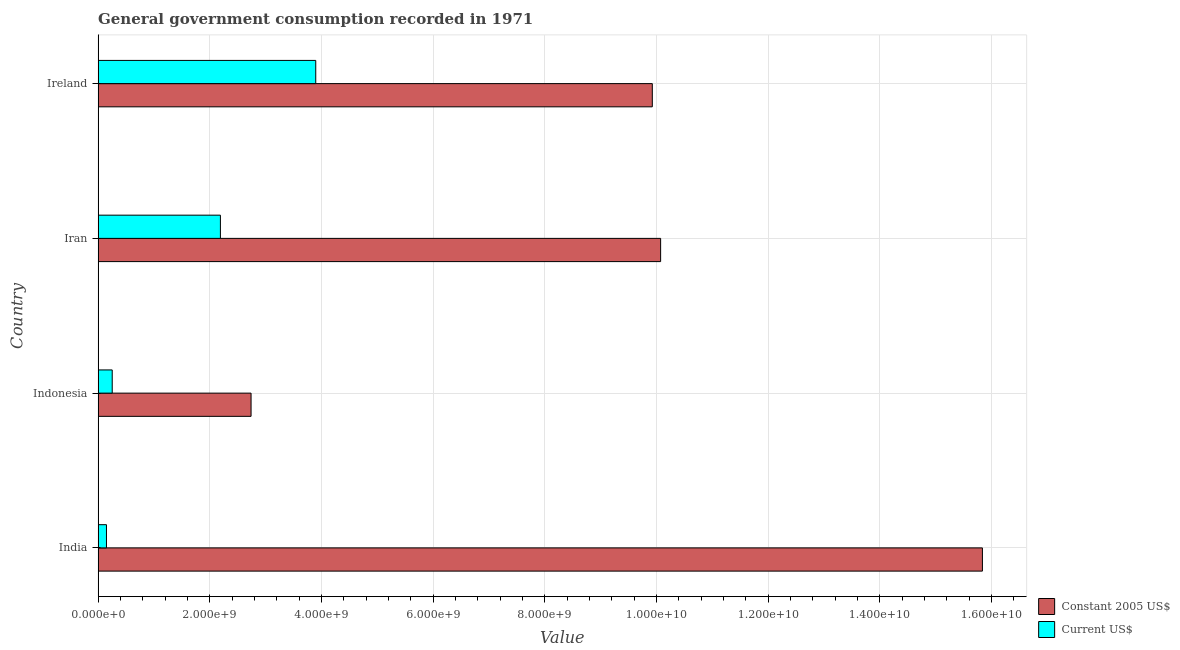How many bars are there on the 4th tick from the bottom?
Ensure brevity in your answer.  2. What is the label of the 4th group of bars from the top?
Ensure brevity in your answer.  India. What is the value consumed in constant 2005 us$ in Indonesia?
Keep it short and to the point. 2.74e+09. Across all countries, what is the maximum value consumed in current us$?
Make the answer very short. 3.90e+09. Across all countries, what is the minimum value consumed in constant 2005 us$?
Your answer should be very brief. 2.74e+09. In which country was the value consumed in constant 2005 us$ minimum?
Give a very brief answer. Indonesia. What is the total value consumed in current us$ in the graph?
Make the answer very short. 6.49e+09. What is the difference between the value consumed in constant 2005 us$ in Indonesia and that in Iran?
Offer a very short reply. -7.33e+09. What is the difference between the value consumed in current us$ in Iran and the value consumed in constant 2005 us$ in Ireland?
Give a very brief answer. -7.73e+09. What is the average value consumed in constant 2005 us$ per country?
Offer a very short reply. 9.64e+09. What is the difference between the value consumed in constant 2005 us$ and value consumed in current us$ in Indonesia?
Offer a very short reply. 2.49e+09. In how many countries, is the value consumed in constant 2005 us$ greater than 13600000000 ?
Offer a terse response. 1. What is the ratio of the value consumed in current us$ in India to that in Ireland?
Offer a very short reply. 0.04. Is the value consumed in constant 2005 us$ in Iran less than that in Ireland?
Your answer should be compact. No. Is the difference between the value consumed in current us$ in India and Iran greater than the difference between the value consumed in constant 2005 us$ in India and Iran?
Your answer should be compact. No. What is the difference between the highest and the second highest value consumed in current us$?
Ensure brevity in your answer.  1.71e+09. What is the difference between the highest and the lowest value consumed in constant 2005 us$?
Your response must be concise. 1.31e+1. In how many countries, is the value consumed in constant 2005 us$ greater than the average value consumed in constant 2005 us$ taken over all countries?
Ensure brevity in your answer.  3. What does the 1st bar from the top in Ireland represents?
Ensure brevity in your answer.  Current US$. What does the 2nd bar from the bottom in Ireland represents?
Offer a very short reply. Current US$. How many bars are there?
Make the answer very short. 8. Does the graph contain any zero values?
Your answer should be compact. No. Does the graph contain grids?
Your answer should be very brief. Yes. Where does the legend appear in the graph?
Keep it short and to the point. Bottom right. How are the legend labels stacked?
Ensure brevity in your answer.  Vertical. What is the title of the graph?
Offer a very short reply. General government consumption recorded in 1971. What is the label or title of the X-axis?
Offer a very short reply. Value. What is the Value in Constant 2005 US$ in India?
Offer a terse response. 1.58e+1. What is the Value in Current US$ in India?
Provide a succinct answer. 1.49e+08. What is the Value in Constant 2005 US$ in Indonesia?
Provide a short and direct response. 2.74e+09. What is the Value of Current US$ in Indonesia?
Provide a succinct answer. 2.52e+08. What is the Value in Constant 2005 US$ in Iran?
Provide a short and direct response. 1.01e+1. What is the Value of Current US$ in Iran?
Offer a very short reply. 2.19e+09. What is the Value of Constant 2005 US$ in Ireland?
Your answer should be compact. 9.92e+09. What is the Value in Current US$ in Ireland?
Make the answer very short. 3.90e+09. Across all countries, what is the maximum Value of Constant 2005 US$?
Your answer should be compact. 1.58e+1. Across all countries, what is the maximum Value in Current US$?
Your response must be concise. 3.90e+09. Across all countries, what is the minimum Value in Constant 2005 US$?
Keep it short and to the point. 2.74e+09. Across all countries, what is the minimum Value in Current US$?
Offer a terse response. 1.49e+08. What is the total Value in Constant 2005 US$ in the graph?
Your answer should be very brief. 3.86e+1. What is the total Value in Current US$ in the graph?
Your answer should be very brief. 6.49e+09. What is the difference between the Value in Constant 2005 US$ in India and that in Indonesia?
Make the answer very short. 1.31e+1. What is the difference between the Value in Current US$ in India and that in Indonesia?
Make the answer very short. -1.03e+08. What is the difference between the Value of Constant 2005 US$ in India and that in Iran?
Keep it short and to the point. 5.76e+09. What is the difference between the Value in Current US$ in India and that in Iran?
Ensure brevity in your answer.  -2.04e+09. What is the difference between the Value of Constant 2005 US$ in India and that in Ireland?
Provide a succinct answer. 5.91e+09. What is the difference between the Value of Current US$ in India and that in Ireland?
Make the answer very short. -3.75e+09. What is the difference between the Value in Constant 2005 US$ in Indonesia and that in Iran?
Make the answer very short. -7.33e+09. What is the difference between the Value of Current US$ in Indonesia and that in Iran?
Make the answer very short. -1.94e+09. What is the difference between the Value of Constant 2005 US$ in Indonesia and that in Ireland?
Give a very brief answer. -7.19e+09. What is the difference between the Value of Current US$ in Indonesia and that in Ireland?
Provide a succinct answer. -3.64e+09. What is the difference between the Value in Constant 2005 US$ in Iran and that in Ireland?
Ensure brevity in your answer.  1.49e+08. What is the difference between the Value of Current US$ in Iran and that in Ireland?
Make the answer very short. -1.71e+09. What is the difference between the Value in Constant 2005 US$ in India and the Value in Current US$ in Indonesia?
Provide a short and direct response. 1.56e+1. What is the difference between the Value of Constant 2005 US$ in India and the Value of Current US$ in Iran?
Provide a short and direct response. 1.36e+1. What is the difference between the Value in Constant 2005 US$ in India and the Value in Current US$ in Ireland?
Ensure brevity in your answer.  1.19e+1. What is the difference between the Value of Constant 2005 US$ in Indonesia and the Value of Current US$ in Iran?
Give a very brief answer. 5.49e+08. What is the difference between the Value in Constant 2005 US$ in Indonesia and the Value in Current US$ in Ireland?
Your answer should be compact. -1.16e+09. What is the difference between the Value of Constant 2005 US$ in Iran and the Value of Current US$ in Ireland?
Your response must be concise. 6.18e+09. What is the average Value of Constant 2005 US$ per country?
Offer a terse response. 9.64e+09. What is the average Value of Current US$ per country?
Give a very brief answer. 1.62e+09. What is the difference between the Value in Constant 2005 US$ and Value in Current US$ in India?
Provide a short and direct response. 1.57e+1. What is the difference between the Value of Constant 2005 US$ and Value of Current US$ in Indonesia?
Your answer should be very brief. 2.49e+09. What is the difference between the Value in Constant 2005 US$ and Value in Current US$ in Iran?
Your answer should be very brief. 7.88e+09. What is the difference between the Value of Constant 2005 US$ and Value of Current US$ in Ireland?
Your response must be concise. 6.03e+09. What is the ratio of the Value of Constant 2005 US$ in India to that in Indonesia?
Offer a very short reply. 5.78. What is the ratio of the Value in Current US$ in India to that in Indonesia?
Keep it short and to the point. 0.59. What is the ratio of the Value in Constant 2005 US$ in India to that in Iran?
Your response must be concise. 1.57. What is the ratio of the Value in Current US$ in India to that in Iran?
Offer a very short reply. 0.07. What is the ratio of the Value in Constant 2005 US$ in India to that in Ireland?
Make the answer very short. 1.6. What is the ratio of the Value of Current US$ in India to that in Ireland?
Your answer should be very brief. 0.04. What is the ratio of the Value in Constant 2005 US$ in Indonesia to that in Iran?
Your answer should be compact. 0.27. What is the ratio of the Value of Current US$ in Indonesia to that in Iran?
Make the answer very short. 0.12. What is the ratio of the Value in Constant 2005 US$ in Indonesia to that in Ireland?
Provide a short and direct response. 0.28. What is the ratio of the Value of Current US$ in Indonesia to that in Ireland?
Your response must be concise. 0.06. What is the ratio of the Value of Current US$ in Iran to that in Ireland?
Keep it short and to the point. 0.56. What is the difference between the highest and the second highest Value of Constant 2005 US$?
Offer a very short reply. 5.76e+09. What is the difference between the highest and the second highest Value of Current US$?
Make the answer very short. 1.71e+09. What is the difference between the highest and the lowest Value of Constant 2005 US$?
Provide a succinct answer. 1.31e+1. What is the difference between the highest and the lowest Value in Current US$?
Provide a short and direct response. 3.75e+09. 